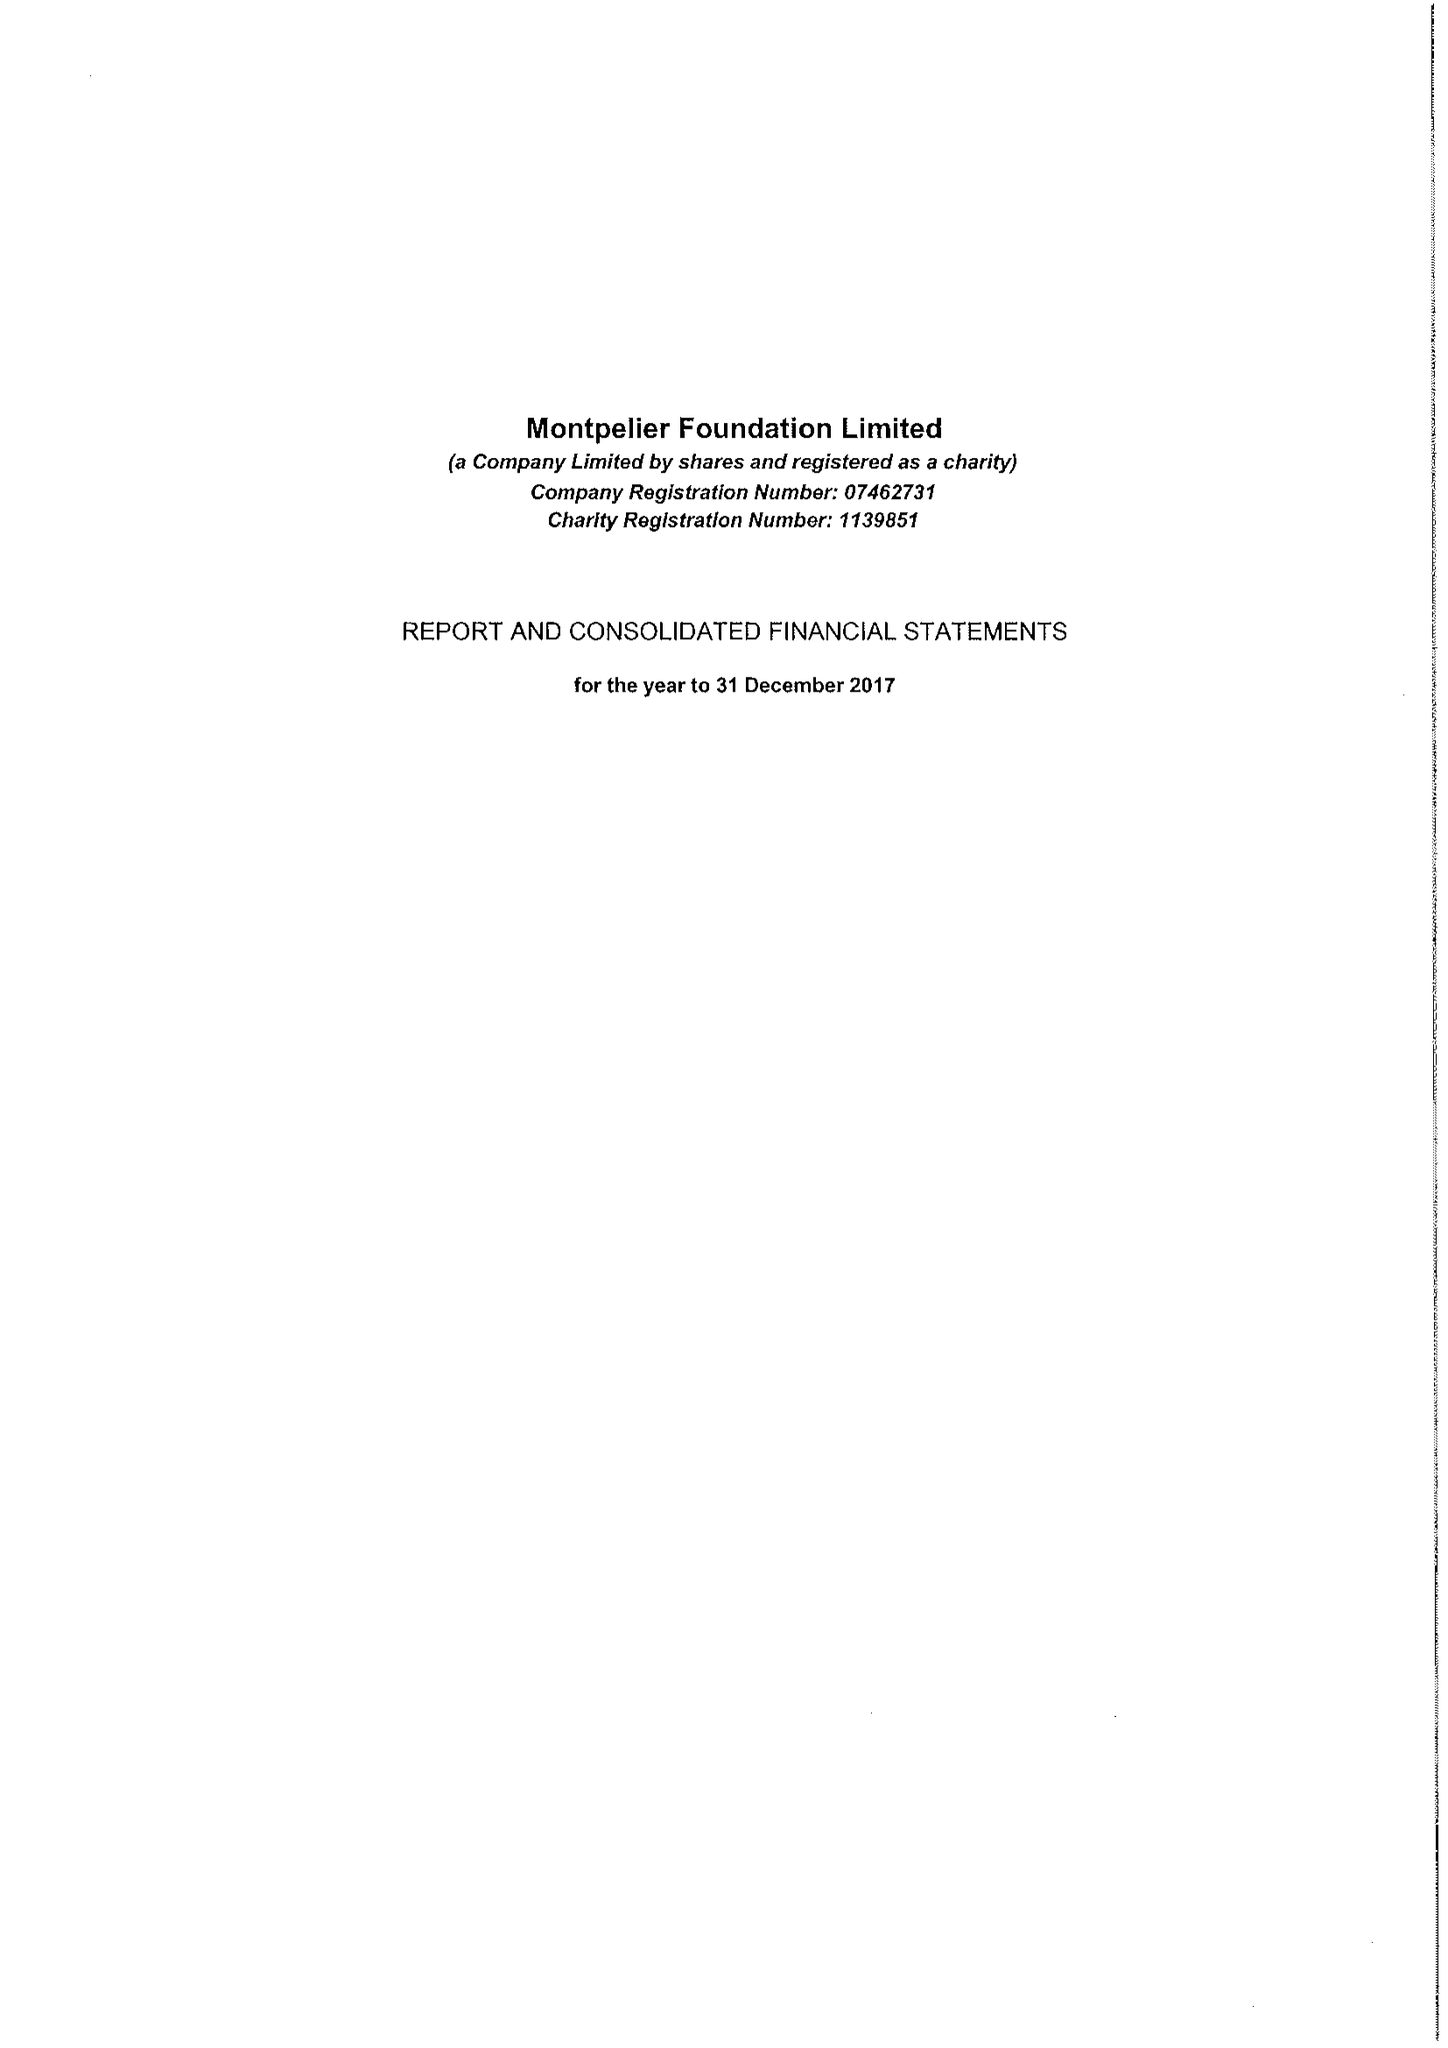What is the value for the address__postcode?
Answer the question using a single word or phrase. SW7 1DN 